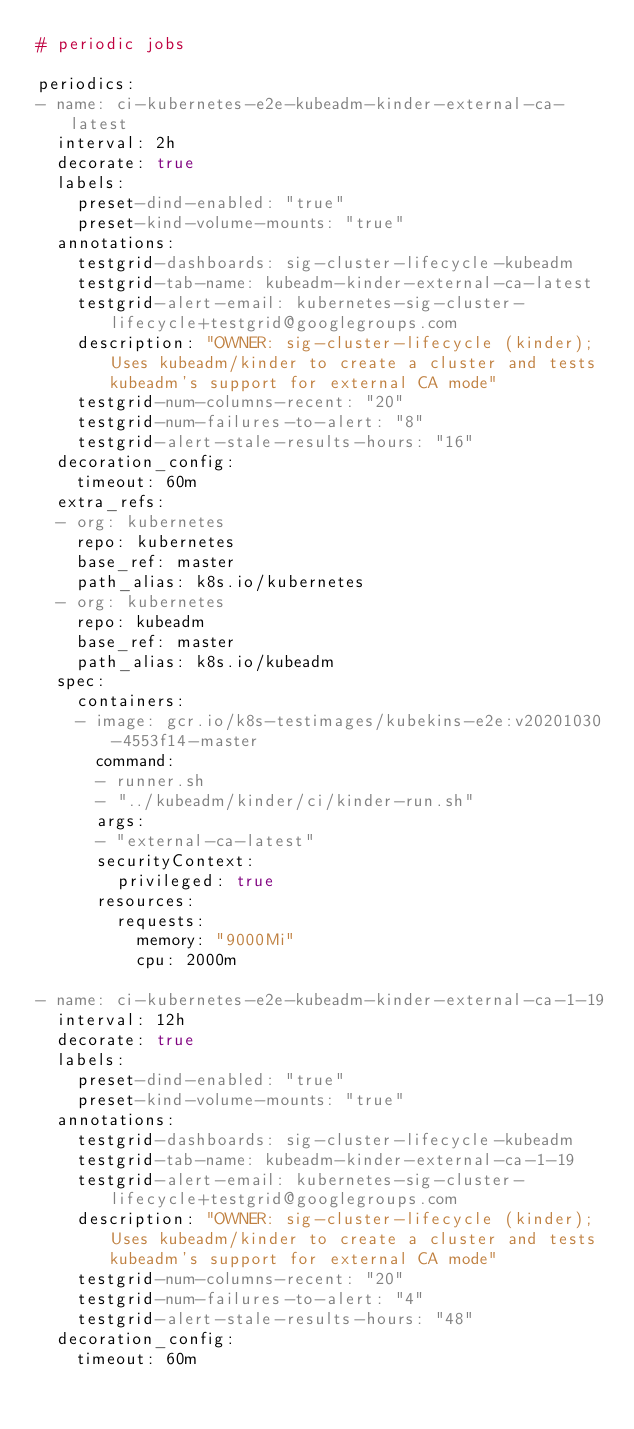Convert code to text. <code><loc_0><loc_0><loc_500><loc_500><_YAML_># periodic jobs

periodics:
- name: ci-kubernetes-e2e-kubeadm-kinder-external-ca-latest
  interval: 2h
  decorate: true
  labels:
    preset-dind-enabled: "true"
    preset-kind-volume-mounts: "true"
  annotations:
    testgrid-dashboards: sig-cluster-lifecycle-kubeadm
    testgrid-tab-name: kubeadm-kinder-external-ca-latest
    testgrid-alert-email: kubernetes-sig-cluster-lifecycle+testgrid@googlegroups.com
    description: "OWNER: sig-cluster-lifecycle (kinder); Uses kubeadm/kinder to create a cluster and tests kubeadm's support for external CA mode"
    testgrid-num-columns-recent: "20"
    testgrid-num-failures-to-alert: "8"
    testgrid-alert-stale-results-hours: "16"
  decoration_config:
    timeout: 60m
  extra_refs:
  - org: kubernetes
    repo: kubernetes
    base_ref: master
    path_alias: k8s.io/kubernetes
  - org: kubernetes
    repo: kubeadm
    base_ref: master
    path_alias: k8s.io/kubeadm
  spec:
    containers:
    - image: gcr.io/k8s-testimages/kubekins-e2e:v20201030-4553f14-master
      command:
      - runner.sh
      - "../kubeadm/kinder/ci/kinder-run.sh"
      args:
      - "external-ca-latest"
      securityContext:
        privileged: true
      resources:
        requests:
          memory: "9000Mi"
          cpu: 2000m

- name: ci-kubernetes-e2e-kubeadm-kinder-external-ca-1-19
  interval: 12h
  decorate: true
  labels:
    preset-dind-enabled: "true"
    preset-kind-volume-mounts: "true"
  annotations:
    testgrid-dashboards: sig-cluster-lifecycle-kubeadm
    testgrid-tab-name: kubeadm-kinder-external-ca-1-19
    testgrid-alert-email: kubernetes-sig-cluster-lifecycle+testgrid@googlegroups.com
    description: "OWNER: sig-cluster-lifecycle (kinder); Uses kubeadm/kinder to create a cluster and tests kubeadm's support for external CA mode"
    testgrid-num-columns-recent: "20"
    testgrid-num-failures-to-alert: "4"
    testgrid-alert-stale-results-hours: "48"
  decoration_config:
    timeout: 60m</code> 